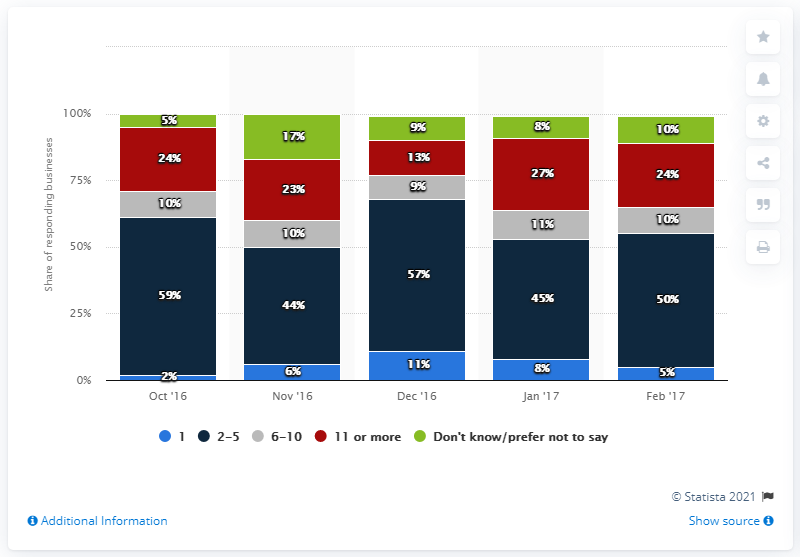Specify some key components in this picture. The highest percentage value in the dark blue bar is 57%. The sum of the highest percentage value in the dark blue bar and the highest percentage value in the light blue bar is 70%. 